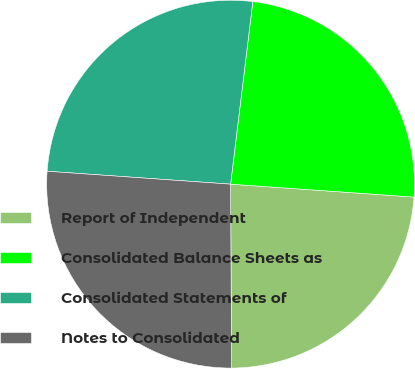<chart> <loc_0><loc_0><loc_500><loc_500><pie_chart><fcel>Report of Independent<fcel>Consolidated Balance Sheets as<fcel>Consolidated Statements of<fcel>Notes to Consolidated<nl><fcel>23.79%<fcel>24.19%<fcel>25.81%<fcel>26.21%<nl></chart> 